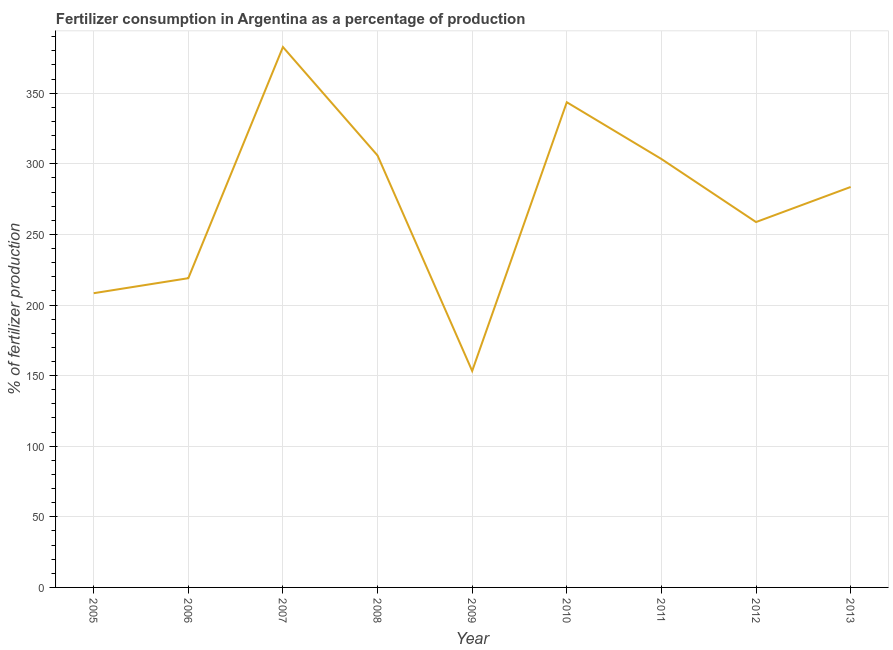What is the amount of fertilizer consumption in 2010?
Your answer should be very brief. 343.59. Across all years, what is the maximum amount of fertilizer consumption?
Your answer should be compact. 382.69. Across all years, what is the minimum amount of fertilizer consumption?
Give a very brief answer. 153.28. In which year was the amount of fertilizer consumption minimum?
Provide a short and direct response. 2009. What is the sum of the amount of fertilizer consumption?
Keep it short and to the point. 2458.5. What is the difference between the amount of fertilizer consumption in 2006 and 2009?
Make the answer very short. 65.7. What is the average amount of fertilizer consumption per year?
Offer a very short reply. 273.17. What is the median amount of fertilizer consumption?
Give a very brief answer. 283.59. In how many years, is the amount of fertilizer consumption greater than 310 %?
Give a very brief answer. 2. Do a majority of the years between 2010 and 2006 (inclusive) have amount of fertilizer consumption greater than 230 %?
Give a very brief answer. Yes. What is the ratio of the amount of fertilizer consumption in 2006 to that in 2007?
Offer a terse response. 0.57. Is the amount of fertilizer consumption in 2006 less than that in 2010?
Keep it short and to the point. Yes. What is the difference between the highest and the second highest amount of fertilizer consumption?
Offer a very short reply. 39.1. What is the difference between the highest and the lowest amount of fertilizer consumption?
Make the answer very short. 229.41. In how many years, is the amount of fertilizer consumption greater than the average amount of fertilizer consumption taken over all years?
Keep it short and to the point. 5. Does the amount of fertilizer consumption monotonically increase over the years?
Your answer should be compact. No. How many lines are there?
Your response must be concise. 1. What is the title of the graph?
Your response must be concise. Fertilizer consumption in Argentina as a percentage of production. What is the label or title of the X-axis?
Your response must be concise. Year. What is the label or title of the Y-axis?
Provide a short and direct response. % of fertilizer production. What is the % of fertilizer production in 2005?
Ensure brevity in your answer.  208.36. What is the % of fertilizer production of 2006?
Make the answer very short. 218.98. What is the % of fertilizer production of 2007?
Offer a terse response. 382.69. What is the % of fertilizer production in 2008?
Your answer should be very brief. 305.88. What is the % of fertilizer production in 2009?
Provide a short and direct response. 153.28. What is the % of fertilizer production of 2010?
Make the answer very short. 343.59. What is the % of fertilizer production in 2011?
Your response must be concise. 303.39. What is the % of fertilizer production of 2012?
Your answer should be very brief. 258.74. What is the % of fertilizer production in 2013?
Your response must be concise. 283.59. What is the difference between the % of fertilizer production in 2005 and 2006?
Ensure brevity in your answer.  -10.62. What is the difference between the % of fertilizer production in 2005 and 2007?
Provide a short and direct response. -174.33. What is the difference between the % of fertilizer production in 2005 and 2008?
Your answer should be very brief. -97.52. What is the difference between the % of fertilizer production in 2005 and 2009?
Your response must be concise. 55.08. What is the difference between the % of fertilizer production in 2005 and 2010?
Offer a terse response. -135.23. What is the difference between the % of fertilizer production in 2005 and 2011?
Your answer should be compact. -95.03. What is the difference between the % of fertilizer production in 2005 and 2012?
Make the answer very short. -50.38. What is the difference between the % of fertilizer production in 2005 and 2013?
Ensure brevity in your answer.  -75.22. What is the difference between the % of fertilizer production in 2006 and 2007?
Keep it short and to the point. -163.71. What is the difference between the % of fertilizer production in 2006 and 2008?
Provide a succinct answer. -86.9. What is the difference between the % of fertilizer production in 2006 and 2009?
Your response must be concise. 65.7. What is the difference between the % of fertilizer production in 2006 and 2010?
Provide a short and direct response. -124.61. What is the difference between the % of fertilizer production in 2006 and 2011?
Offer a very short reply. -84.41. What is the difference between the % of fertilizer production in 2006 and 2012?
Provide a short and direct response. -39.76. What is the difference between the % of fertilizer production in 2006 and 2013?
Your response must be concise. -64.6. What is the difference between the % of fertilizer production in 2007 and 2008?
Provide a short and direct response. 76.81. What is the difference between the % of fertilizer production in 2007 and 2009?
Your answer should be compact. 229.41. What is the difference between the % of fertilizer production in 2007 and 2010?
Offer a very short reply. 39.1. What is the difference between the % of fertilizer production in 2007 and 2011?
Give a very brief answer. 79.3. What is the difference between the % of fertilizer production in 2007 and 2012?
Provide a succinct answer. 123.95. What is the difference between the % of fertilizer production in 2007 and 2013?
Provide a short and direct response. 99.1. What is the difference between the % of fertilizer production in 2008 and 2009?
Offer a very short reply. 152.6. What is the difference between the % of fertilizer production in 2008 and 2010?
Keep it short and to the point. -37.71. What is the difference between the % of fertilizer production in 2008 and 2011?
Ensure brevity in your answer.  2.49. What is the difference between the % of fertilizer production in 2008 and 2012?
Offer a terse response. 47.14. What is the difference between the % of fertilizer production in 2008 and 2013?
Offer a terse response. 22.29. What is the difference between the % of fertilizer production in 2009 and 2010?
Your response must be concise. -190.31. What is the difference between the % of fertilizer production in 2009 and 2011?
Keep it short and to the point. -150.11. What is the difference between the % of fertilizer production in 2009 and 2012?
Ensure brevity in your answer.  -105.46. What is the difference between the % of fertilizer production in 2009 and 2013?
Your answer should be compact. -130.31. What is the difference between the % of fertilizer production in 2010 and 2011?
Your answer should be compact. 40.2. What is the difference between the % of fertilizer production in 2010 and 2012?
Keep it short and to the point. 84.85. What is the difference between the % of fertilizer production in 2010 and 2013?
Offer a very short reply. 60. What is the difference between the % of fertilizer production in 2011 and 2012?
Ensure brevity in your answer.  44.65. What is the difference between the % of fertilizer production in 2011 and 2013?
Ensure brevity in your answer.  19.8. What is the difference between the % of fertilizer production in 2012 and 2013?
Provide a succinct answer. -24.85. What is the ratio of the % of fertilizer production in 2005 to that in 2006?
Keep it short and to the point. 0.95. What is the ratio of the % of fertilizer production in 2005 to that in 2007?
Your answer should be compact. 0.54. What is the ratio of the % of fertilizer production in 2005 to that in 2008?
Your answer should be compact. 0.68. What is the ratio of the % of fertilizer production in 2005 to that in 2009?
Offer a very short reply. 1.36. What is the ratio of the % of fertilizer production in 2005 to that in 2010?
Your answer should be very brief. 0.61. What is the ratio of the % of fertilizer production in 2005 to that in 2011?
Provide a succinct answer. 0.69. What is the ratio of the % of fertilizer production in 2005 to that in 2012?
Give a very brief answer. 0.81. What is the ratio of the % of fertilizer production in 2005 to that in 2013?
Keep it short and to the point. 0.73. What is the ratio of the % of fertilizer production in 2006 to that in 2007?
Ensure brevity in your answer.  0.57. What is the ratio of the % of fertilizer production in 2006 to that in 2008?
Offer a terse response. 0.72. What is the ratio of the % of fertilizer production in 2006 to that in 2009?
Your response must be concise. 1.43. What is the ratio of the % of fertilizer production in 2006 to that in 2010?
Give a very brief answer. 0.64. What is the ratio of the % of fertilizer production in 2006 to that in 2011?
Offer a very short reply. 0.72. What is the ratio of the % of fertilizer production in 2006 to that in 2012?
Your answer should be very brief. 0.85. What is the ratio of the % of fertilizer production in 2006 to that in 2013?
Ensure brevity in your answer.  0.77. What is the ratio of the % of fertilizer production in 2007 to that in 2008?
Your answer should be very brief. 1.25. What is the ratio of the % of fertilizer production in 2007 to that in 2009?
Offer a terse response. 2.5. What is the ratio of the % of fertilizer production in 2007 to that in 2010?
Your answer should be compact. 1.11. What is the ratio of the % of fertilizer production in 2007 to that in 2011?
Your answer should be very brief. 1.26. What is the ratio of the % of fertilizer production in 2007 to that in 2012?
Keep it short and to the point. 1.48. What is the ratio of the % of fertilizer production in 2007 to that in 2013?
Your answer should be compact. 1.35. What is the ratio of the % of fertilizer production in 2008 to that in 2009?
Give a very brief answer. 2. What is the ratio of the % of fertilizer production in 2008 to that in 2010?
Ensure brevity in your answer.  0.89. What is the ratio of the % of fertilizer production in 2008 to that in 2012?
Offer a terse response. 1.18. What is the ratio of the % of fertilizer production in 2008 to that in 2013?
Your answer should be compact. 1.08. What is the ratio of the % of fertilizer production in 2009 to that in 2010?
Offer a terse response. 0.45. What is the ratio of the % of fertilizer production in 2009 to that in 2011?
Ensure brevity in your answer.  0.51. What is the ratio of the % of fertilizer production in 2009 to that in 2012?
Ensure brevity in your answer.  0.59. What is the ratio of the % of fertilizer production in 2009 to that in 2013?
Keep it short and to the point. 0.54. What is the ratio of the % of fertilizer production in 2010 to that in 2011?
Provide a succinct answer. 1.13. What is the ratio of the % of fertilizer production in 2010 to that in 2012?
Your answer should be compact. 1.33. What is the ratio of the % of fertilizer production in 2010 to that in 2013?
Keep it short and to the point. 1.21. What is the ratio of the % of fertilizer production in 2011 to that in 2012?
Keep it short and to the point. 1.17. What is the ratio of the % of fertilizer production in 2011 to that in 2013?
Provide a succinct answer. 1.07. What is the ratio of the % of fertilizer production in 2012 to that in 2013?
Your response must be concise. 0.91. 